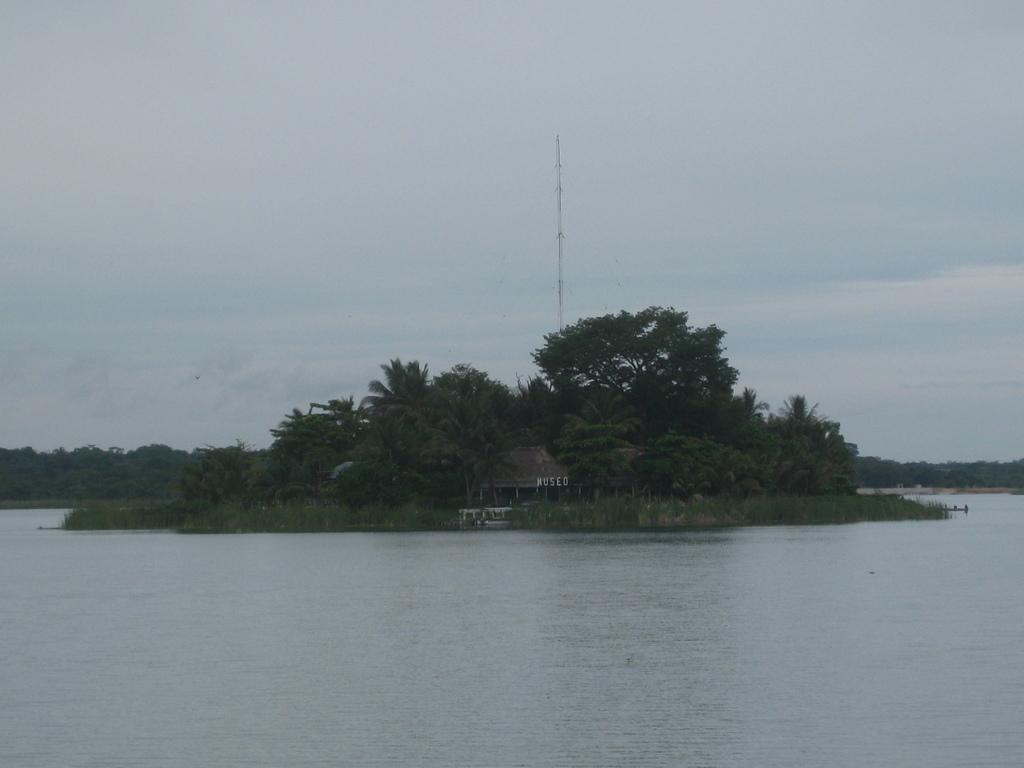What is the primary element visible in the image? There is water in the image. What can be seen in the distance behind the water? There is a house and trees in the background of the image. What type of wool is being used to knit the cat in the image? There is no cat or wool present in the image. 